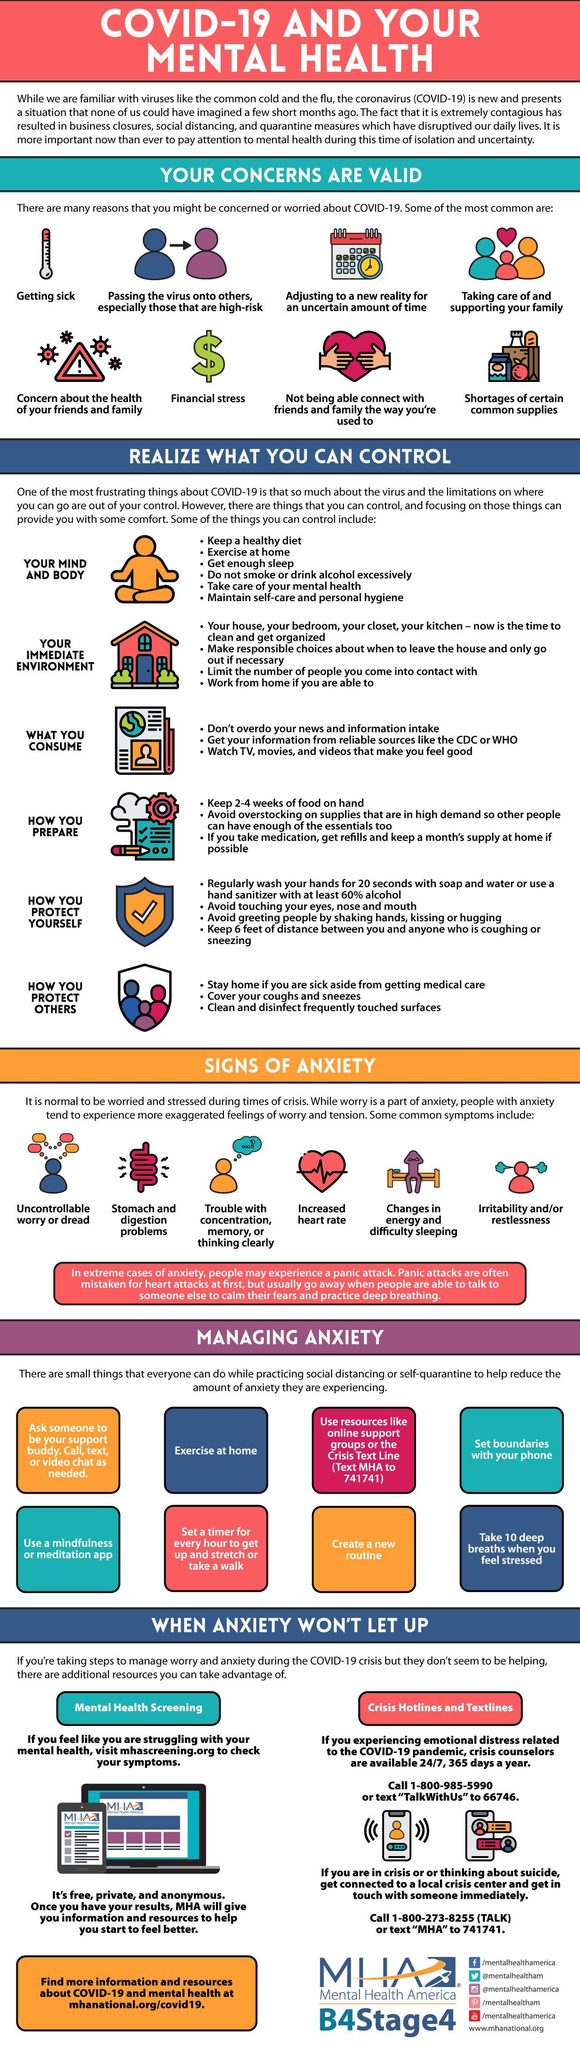To manage anxiety, who can we call, test, or video chat as needed
Answer the question with a short phrase. support buddy what are the additional resources available to manage anxiety when anxiety wont let up Mental Health Screening, Crisis Hotlines and textlines What concern is shown by a thermometer getting sick Control of what factor is shown by the picutre of a house your immediate environment How often should we stretch or take a walk to manage anxiety every hour what concern is shown by the dollar sign financial stress how many factors can be controlled as shown here 6 how many reasons have been shown 8 